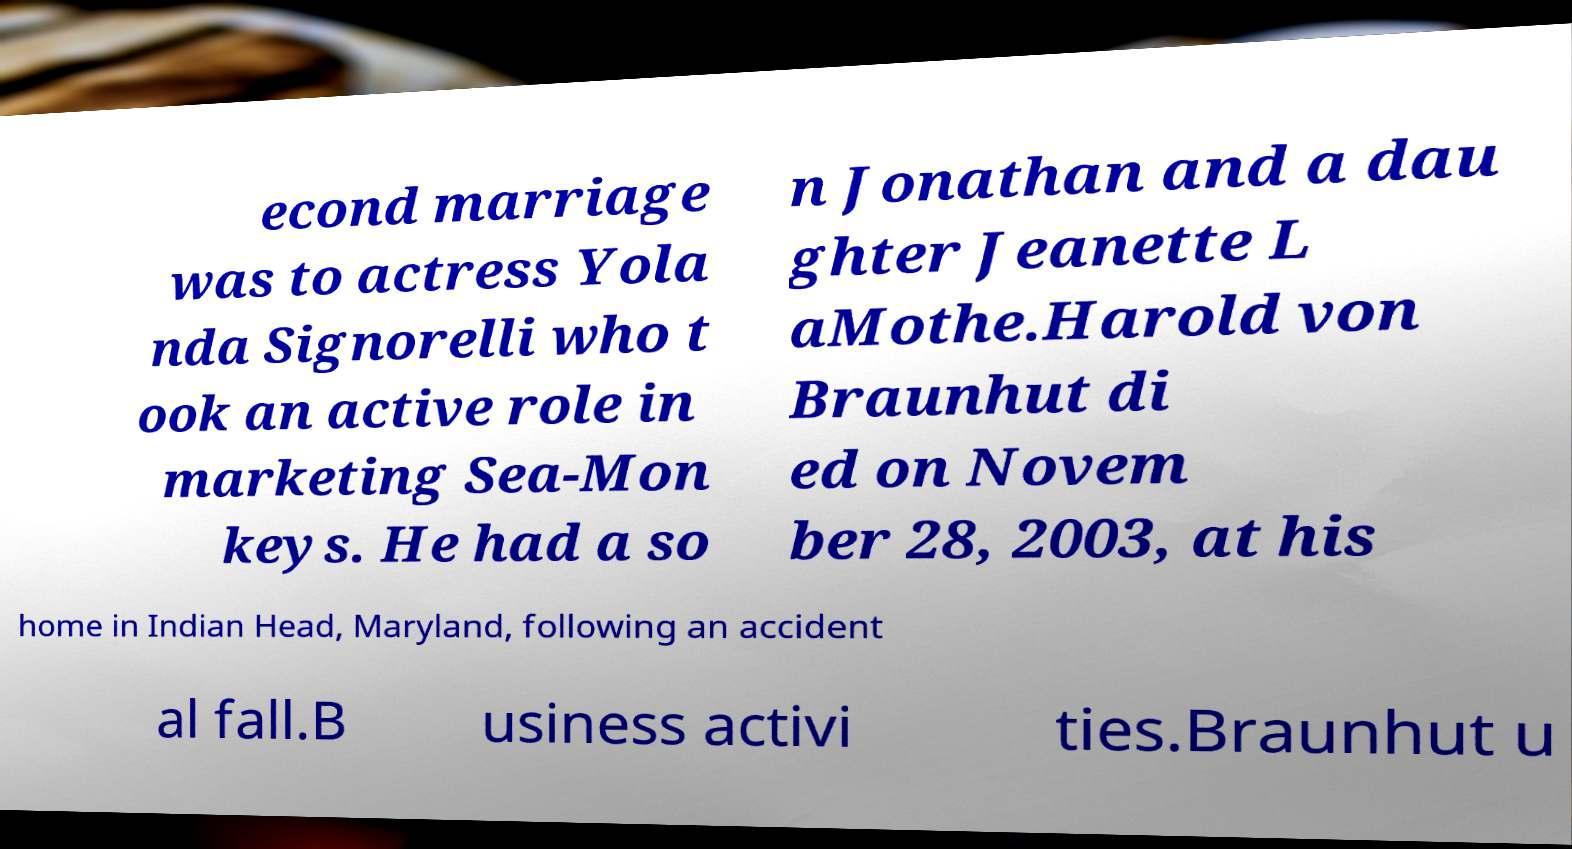Can you read and provide the text displayed in the image?This photo seems to have some interesting text. Can you extract and type it out for me? econd marriage was to actress Yola nda Signorelli who t ook an active role in marketing Sea-Mon keys. He had a so n Jonathan and a dau ghter Jeanette L aMothe.Harold von Braunhut di ed on Novem ber 28, 2003, at his home in Indian Head, Maryland, following an accident al fall.B usiness activi ties.Braunhut u 